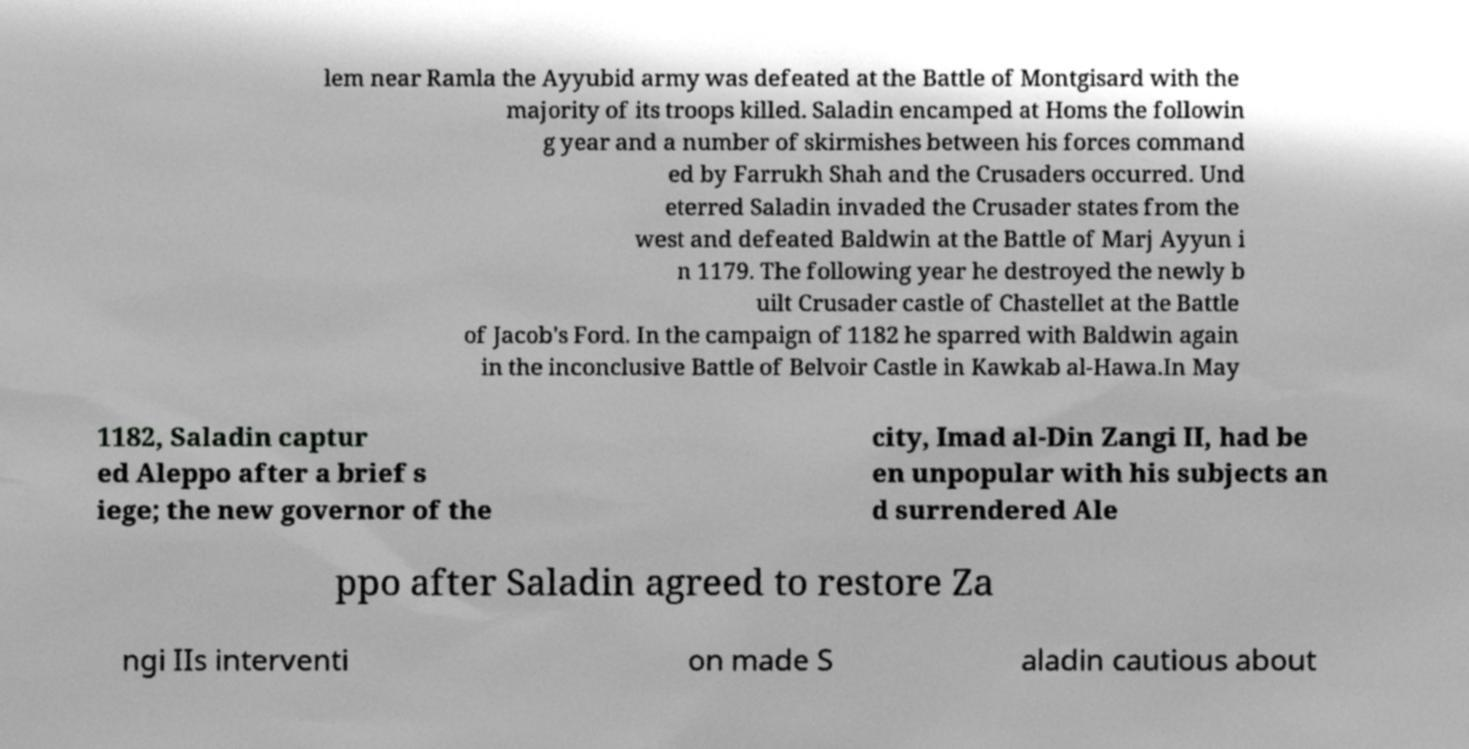Can you read and provide the text displayed in the image?This photo seems to have some interesting text. Can you extract and type it out for me? lem near Ramla the Ayyubid army was defeated at the Battle of Montgisard with the majority of its troops killed. Saladin encamped at Homs the followin g year and a number of skirmishes between his forces command ed by Farrukh Shah and the Crusaders occurred. Und eterred Saladin invaded the Crusader states from the west and defeated Baldwin at the Battle of Marj Ayyun i n 1179. The following year he destroyed the newly b uilt Crusader castle of Chastellet at the Battle of Jacob's Ford. In the campaign of 1182 he sparred with Baldwin again in the inconclusive Battle of Belvoir Castle in Kawkab al-Hawa.In May 1182, Saladin captur ed Aleppo after a brief s iege; the new governor of the city, Imad al-Din Zangi II, had be en unpopular with his subjects an d surrendered Ale ppo after Saladin agreed to restore Za ngi IIs interventi on made S aladin cautious about 